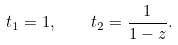Convert formula to latex. <formula><loc_0><loc_0><loc_500><loc_500>t _ { 1 } = 1 , \quad t _ { 2 } = \frac { 1 } { 1 - z } .</formula> 